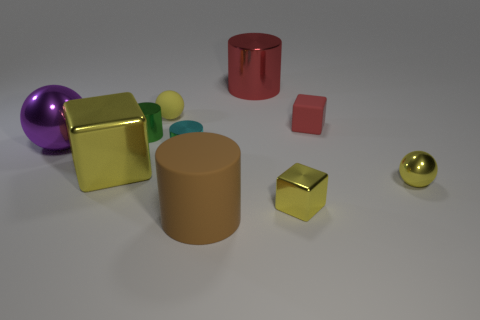Can you describe the texture of the objects? The objects appear to have varying textures. The cylinders and cubes, for example, have a matte surface with a smooth texture. In contrast, the two spheres with shiny surfaces suggest a smooth and possibly slippery texture due to their glossy finish. Which of these textures would be most comfortable to hold? Comfort can be subjective, but generally, the matte surfaces of the cubes and cylinders may provide a better grip and would likely be more comfortable to hold without slipping. 